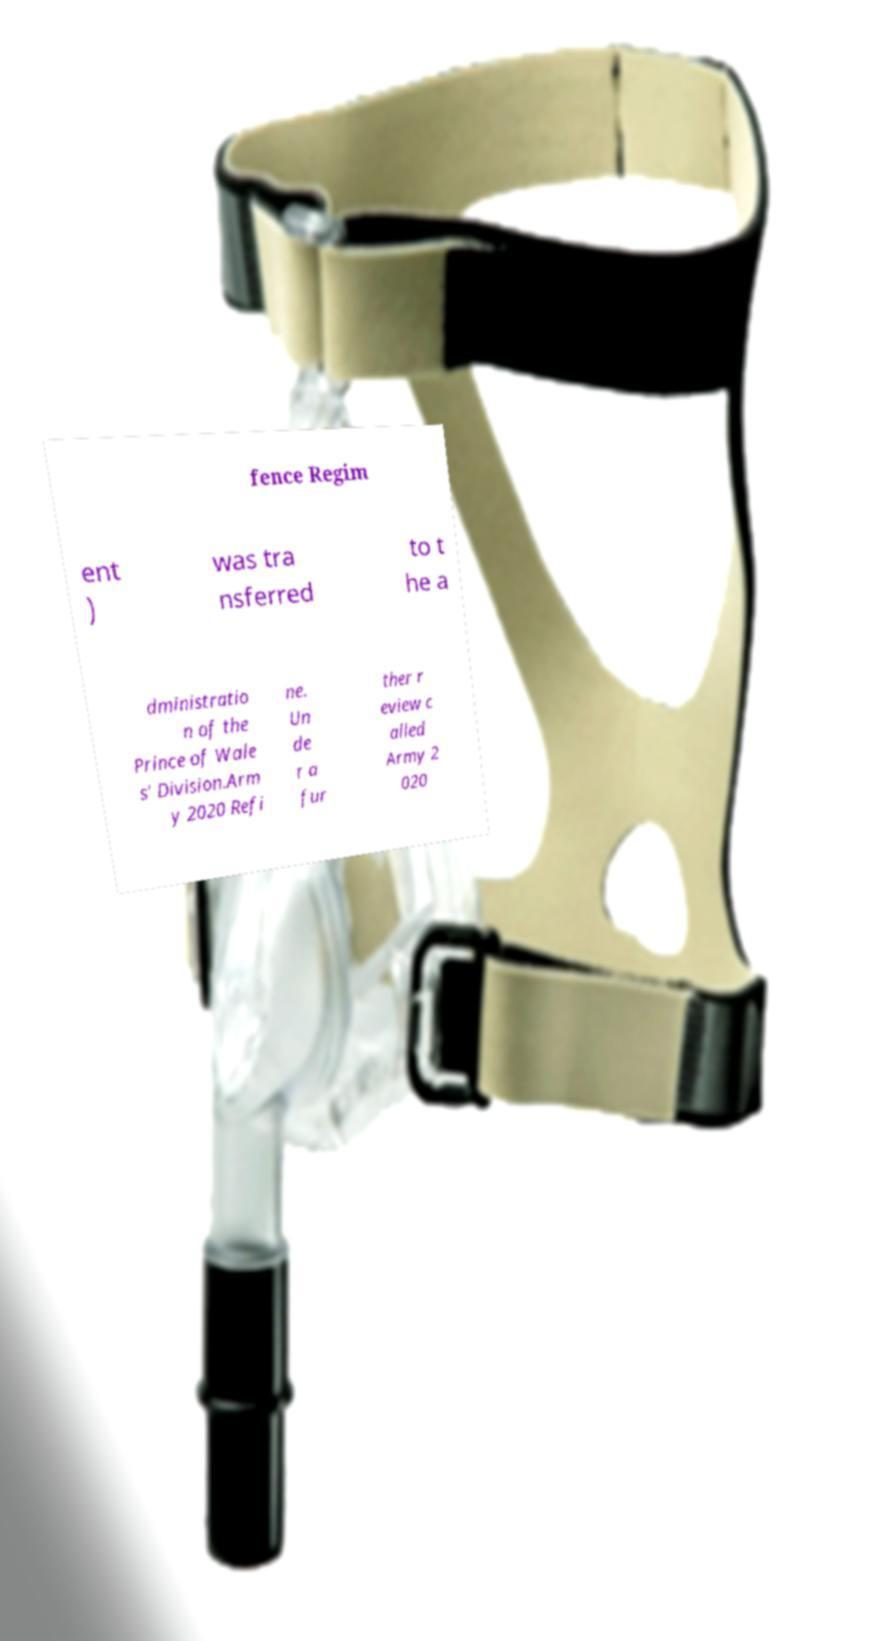I need the written content from this picture converted into text. Can you do that? fence Regim ent ) was tra nsferred to t he a dministratio n of the Prince of Wale s' Division.Arm y 2020 Refi ne. Un de r a fur ther r eview c alled Army 2 020 